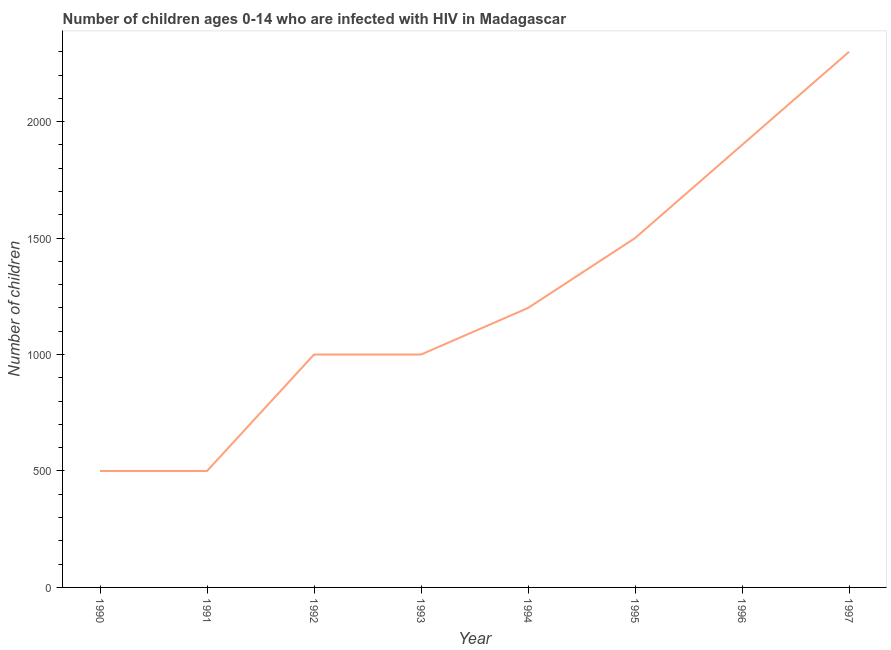What is the number of children living with hiv in 1991?
Provide a short and direct response. 500. Across all years, what is the maximum number of children living with hiv?
Offer a very short reply. 2300. Across all years, what is the minimum number of children living with hiv?
Provide a succinct answer. 500. In which year was the number of children living with hiv minimum?
Offer a terse response. 1990. What is the sum of the number of children living with hiv?
Keep it short and to the point. 9900. What is the difference between the number of children living with hiv in 1993 and 1995?
Your response must be concise. -500. What is the average number of children living with hiv per year?
Your answer should be compact. 1237.5. What is the median number of children living with hiv?
Make the answer very short. 1100. Do a majority of the years between 1990 and 1995 (inclusive) have number of children living with hiv greater than 1100 ?
Provide a short and direct response. No. What is the ratio of the number of children living with hiv in 1996 to that in 1997?
Your answer should be compact. 0.83. Is the number of children living with hiv in 1990 less than that in 1997?
Ensure brevity in your answer.  Yes. Is the difference between the number of children living with hiv in 1991 and 1997 greater than the difference between any two years?
Your response must be concise. Yes. What is the difference between the highest and the lowest number of children living with hiv?
Your answer should be compact. 1800. How many lines are there?
Ensure brevity in your answer.  1. Are the values on the major ticks of Y-axis written in scientific E-notation?
Offer a terse response. No. Does the graph contain grids?
Offer a very short reply. No. What is the title of the graph?
Provide a succinct answer. Number of children ages 0-14 who are infected with HIV in Madagascar. What is the label or title of the Y-axis?
Give a very brief answer. Number of children. What is the Number of children in 1991?
Your response must be concise. 500. What is the Number of children of 1993?
Your response must be concise. 1000. What is the Number of children of 1994?
Keep it short and to the point. 1200. What is the Number of children of 1995?
Make the answer very short. 1500. What is the Number of children in 1996?
Provide a short and direct response. 1900. What is the Number of children of 1997?
Offer a terse response. 2300. What is the difference between the Number of children in 1990 and 1991?
Your response must be concise. 0. What is the difference between the Number of children in 1990 and 1992?
Provide a succinct answer. -500. What is the difference between the Number of children in 1990 and 1993?
Keep it short and to the point. -500. What is the difference between the Number of children in 1990 and 1994?
Provide a succinct answer. -700. What is the difference between the Number of children in 1990 and 1995?
Give a very brief answer. -1000. What is the difference between the Number of children in 1990 and 1996?
Provide a succinct answer. -1400. What is the difference between the Number of children in 1990 and 1997?
Provide a short and direct response. -1800. What is the difference between the Number of children in 1991 and 1992?
Give a very brief answer. -500. What is the difference between the Number of children in 1991 and 1993?
Provide a short and direct response. -500. What is the difference between the Number of children in 1991 and 1994?
Your answer should be very brief. -700. What is the difference between the Number of children in 1991 and 1995?
Make the answer very short. -1000. What is the difference between the Number of children in 1991 and 1996?
Provide a short and direct response. -1400. What is the difference between the Number of children in 1991 and 1997?
Offer a very short reply. -1800. What is the difference between the Number of children in 1992 and 1994?
Your response must be concise. -200. What is the difference between the Number of children in 1992 and 1995?
Your answer should be compact. -500. What is the difference between the Number of children in 1992 and 1996?
Provide a succinct answer. -900. What is the difference between the Number of children in 1992 and 1997?
Your answer should be compact. -1300. What is the difference between the Number of children in 1993 and 1994?
Offer a terse response. -200. What is the difference between the Number of children in 1993 and 1995?
Your answer should be compact. -500. What is the difference between the Number of children in 1993 and 1996?
Provide a succinct answer. -900. What is the difference between the Number of children in 1993 and 1997?
Provide a succinct answer. -1300. What is the difference between the Number of children in 1994 and 1995?
Your answer should be very brief. -300. What is the difference between the Number of children in 1994 and 1996?
Provide a succinct answer. -700. What is the difference between the Number of children in 1994 and 1997?
Provide a succinct answer. -1100. What is the difference between the Number of children in 1995 and 1996?
Your answer should be compact. -400. What is the difference between the Number of children in 1995 and 1997?
Keep it short and to the point. -800. What is the difference between the Number of children in 1996 and 1997?
Offer a terse response. -400. What is the ratio of the Number of children in 1990 to that in 1991?
Provide a succinct answer. 1. What is the ratio of the Number of children in 1990 to that in 1992?
Your response must be concise. 0.5. What is the ratio of the Number of children in 1990 to that in 1993?
Offer a very short reply. 0.5. What is the ratio of the Number of children in 1990 to that in 1994?
Offer a terse response. 0.42. What is the ratio of the Number of children in 1990 to that in 1995?
Ensure brevity in your answer.  0.33. What is the ratio of the Number of children in 1990 to that in 1996?
Give a very brief answer. 0.26. What is the ratio of the Number of children in 1990 to that in 1997?
Offer a terse response. 0.22. What is the ratio of the Number of children in 1991 to that in 1992?
Keep it short and to the point. 0.5. What is the ratio of the Number of children in 1991 to that in 1993?
Offer a very short reply. 0.5. What is the ratio of the Number of children in 1991 to that in 1994?
Ensure brevity in your answer.  0.42. What is the ratio of the Number of children in 1991 to that in 1995?
Give a very brief answer. 0.33. What is the ratio of the Number of children in 1991 to that in 1996?
Give a very brief answer. 0.26. What is the ratio of the Number of children in 1991 to that in 1997?
Give a very brief answer. 0.22. What is the ratio of the Number of children in 1992 to that in 1993?
Offer a terse response. 1. What is the ratio of the Number of children in 1992 to that in 1994?
Provide a short and direct response. 0.83. What is the ratio of the Number of children in 1992 to that in 1995?
Keep it short and to the point. 0.67. What is the ratio of the Number of children in 1992 to that in 1996?
Your response must be concise. 0.53. What is the ratio of the Number of children in 1992 to that in 1997?
Provide a short and direct response. 0.43. What is the ratio of the Number of children in 1993 to that in 1994?
Provide a short and direct response. 0.83. What is the ratio of the Number of children in 1993 to that in 1995?
Keep it short and to the point. 0.67. What is the ratio of the Number of children in 1993 to that in 1996?
Give a very brief answer. 0.53. What is the ratio of the Number of children in 1993 to that in 1997?
Make the answer very short. 0.43. What is the ratio of the Number of children in 1994 to that in 1996?
Your answer should be very brief. 0.63. What is the ratio of the Number of children in 1994 to that in 1997?
Ensure brevity in your answer.  0.52. What is the ratio of the Number of children in 1995 to that in 1996?
Your answer should be compact. 0.79. What is the ratio of the Number of children in 1995 to that in 1997?
Keep it short and to the point. 0.65. What is the ratio of the Number of children in 1996 to that in 1997?
Provide a succinct answer. 0.83. 